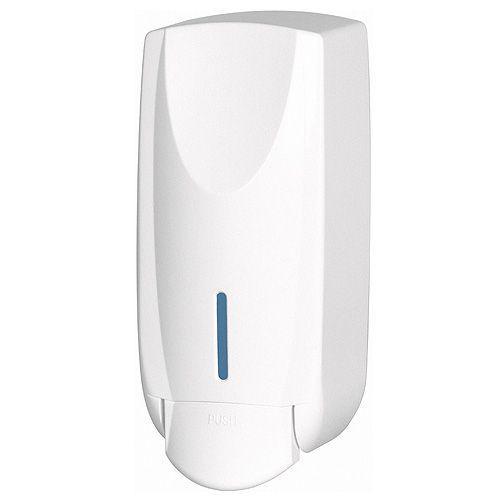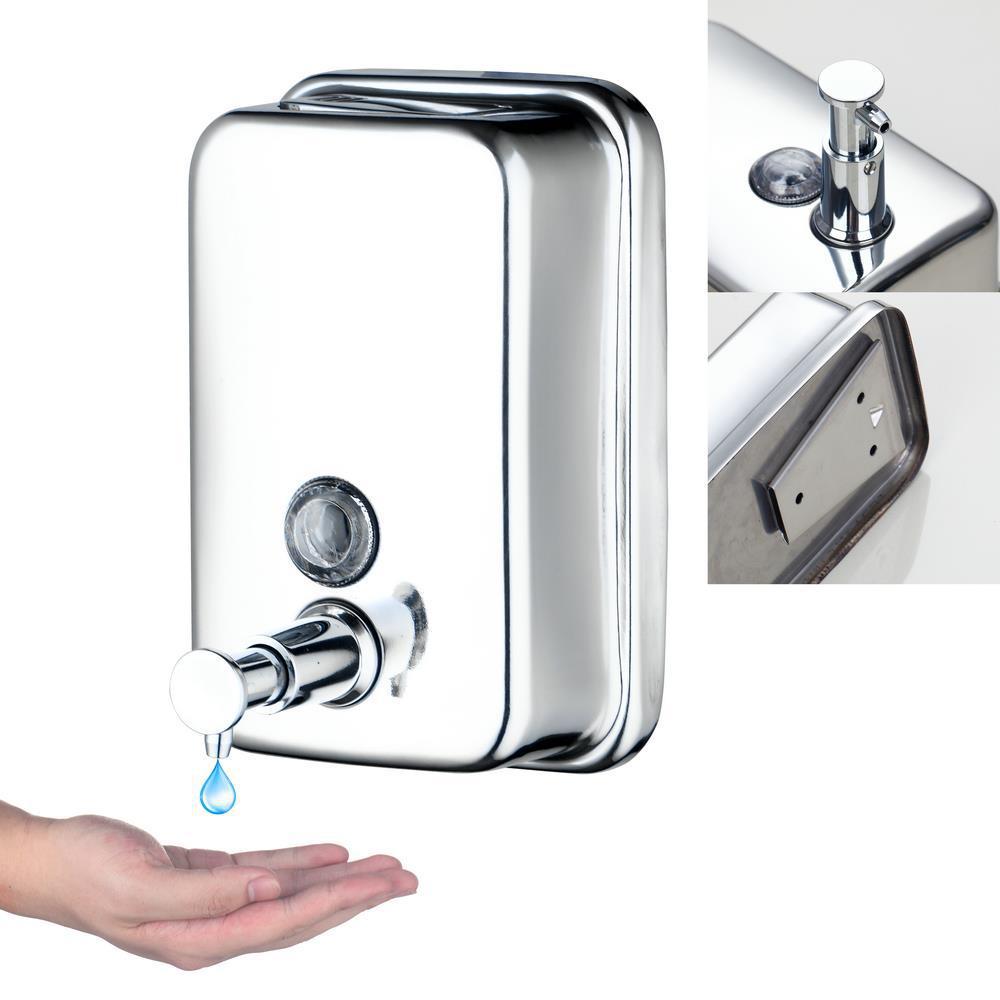The first image is the image on the left, the second image is the image on the right. Assess this claim about the two images: "At least one image includes a chrome-finish dispenser.". Correct or not? Answer yes or no. Yes. 